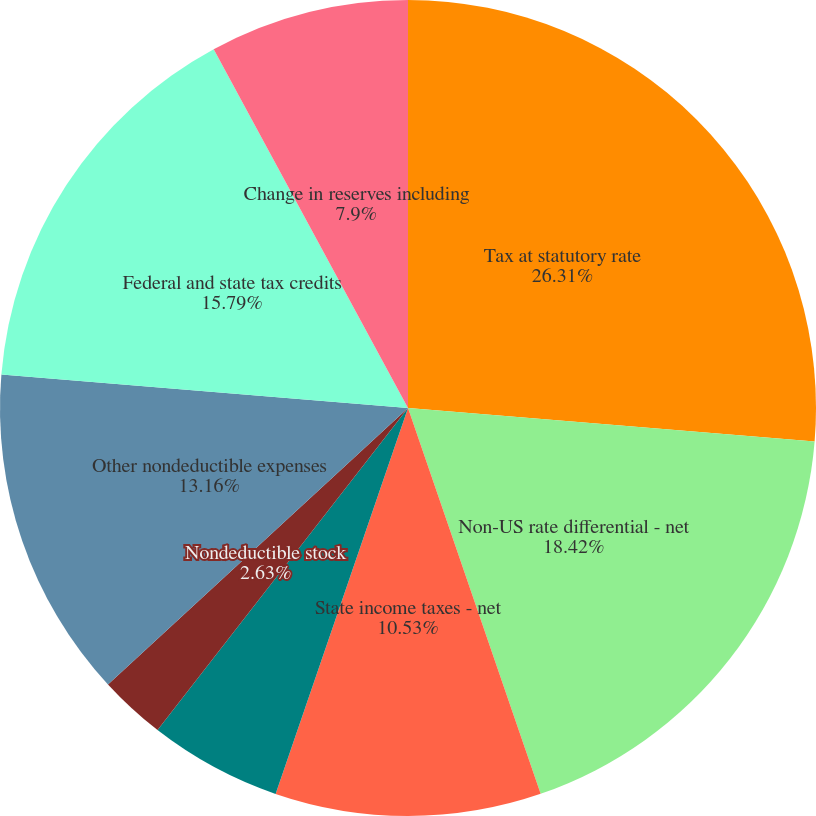<chart> <loc_0><loc_0><loc_500><loc_500><pie_chart><fcel>Tax at statutory rate<fcel>Non-US rate differential - net<fcel>State income taxes - net<fcel>Effect of changes in enacted<fcel>Nondeductible stock<fcel>Other nondeductible expenses<fcel>Federal and state tax credits<fcel>Change in reserves including<fcel>Other - net<nl><fcel>26.31%<fcel>18.42%<fcel>10.53%<fcel>5.26%<fcel>2.63%<fcel>13.16%<fcel>15.79%<fcel>7.9%<fcel>0.0%<nl></chart> 